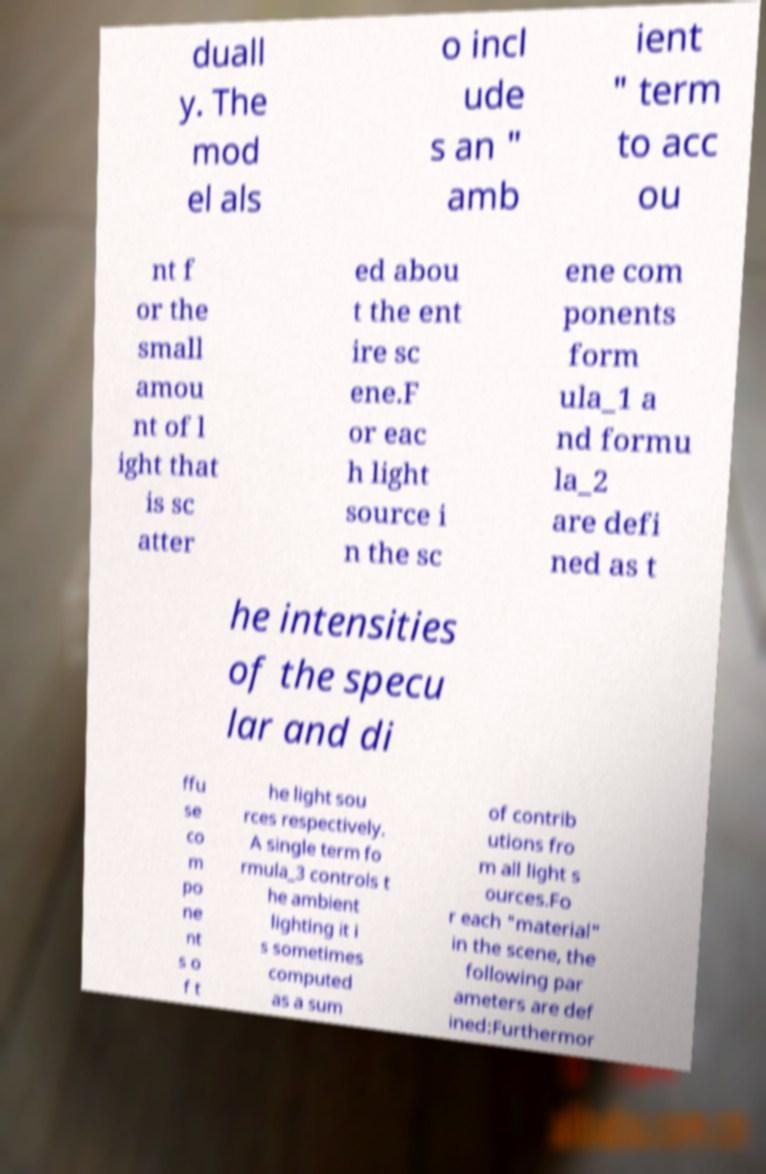For documentation purposes, I need the text within this image transcribed. Could you provide that? duall y. The mod el als o incl ude s an " amb ient " term to acc ou nt f or the small amou nt of l ight that is sc atter ed abou t the ent ire sc ene.F or eac h light source i n the sc ene com ponents form ula_1 a nd formu la_2 are defi ned as t he intensities of the specu lar and di ffu se co m po ne nt s o f t he light sou rces respectively. A single term fo rmula_3 controls t he ambient lighting it i s sometimes computed as a sum of contrib utions fro m all light s ources.Fo r each "material" in the scene, the following par ameters are def ined:Furthermor 